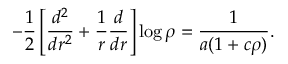Convert formula to latex. <formula><loc_0><loc_0><loc_500><loc_500>- \frac { 1 } { 2 } \left [ \frac { d ^ { 2 } } { d r ^ { 2 } } + \frac { 1 } { r } \frac { d } d r } \right ] \log \rho = \frac { 1 } a ( 1 + c \rho ) } .</formula> 